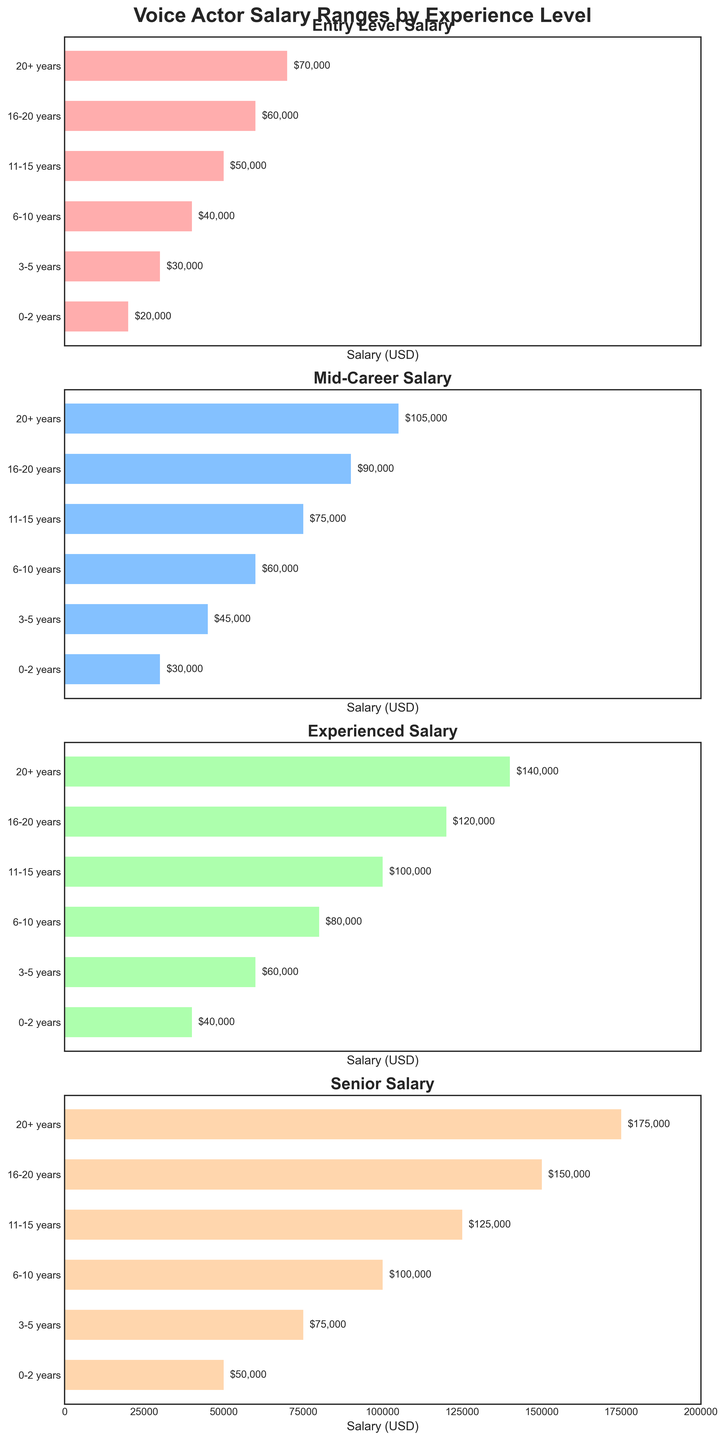What's the average salary for a voice actor with 11-15 years of experience across all categories? Add the salaries for all categories for 11-15 years and then divide by the number of categories. The sum is $50000 (Entry Level) + $75000 (Mid-Career) + $100000 (Experienced) + $125000 (Senior) = $350000. Divide by 4 to get the average: $350000 / 4 = $87500
Answer: $87500 Between the Entry Level and Mid-Career, which experience level shows a more considerable salary increase from 0-2 years to 3-5 years? The Entry Level salary increases from $20000 to $30000, a $10000 increase. The Mid-Career salary rises from $30000 to $45000, a $15000 increase. Therefore, the Mid-Career experience level shows a more considerable salary increase.
Answer: Mid-Career Which experience level shows the smallest salary range between Entry Level and Senior categories? The salary range is found by subtracting the Entry Level salary from the Senior salary for each experience level. For 0-2 years: $50000 - $20000 = $30000. For 3-5 years: $75000 - $30000 = $45000. For 6-10 years: $100000 - $40000 = $60000. For 11-15 years: $125000 - $50000 = $75000. For 16-20 years: $150000 - $60000 = $90000. For 20+ years: $175000 - $70000 = $105000. The smallest range is for the 0-2 years experience level.
Answer: 0-2 years Considering 20+ years of experience, what is the salary difference between Mid-Career and Experienced categories? For 20+ years of experience, the Mid-Career salary is $105000 and the Experienced salary is $140000. The difference is $140000 - $105000 = $35000.
Answer: $35000 What is the highest salary value displayed on the figure for any experience level and category? By examining the highest values across all categories and experience levels, the maximum salary value is $175000 for the Senior category with 20+ years of experience.
Answer: $175000 